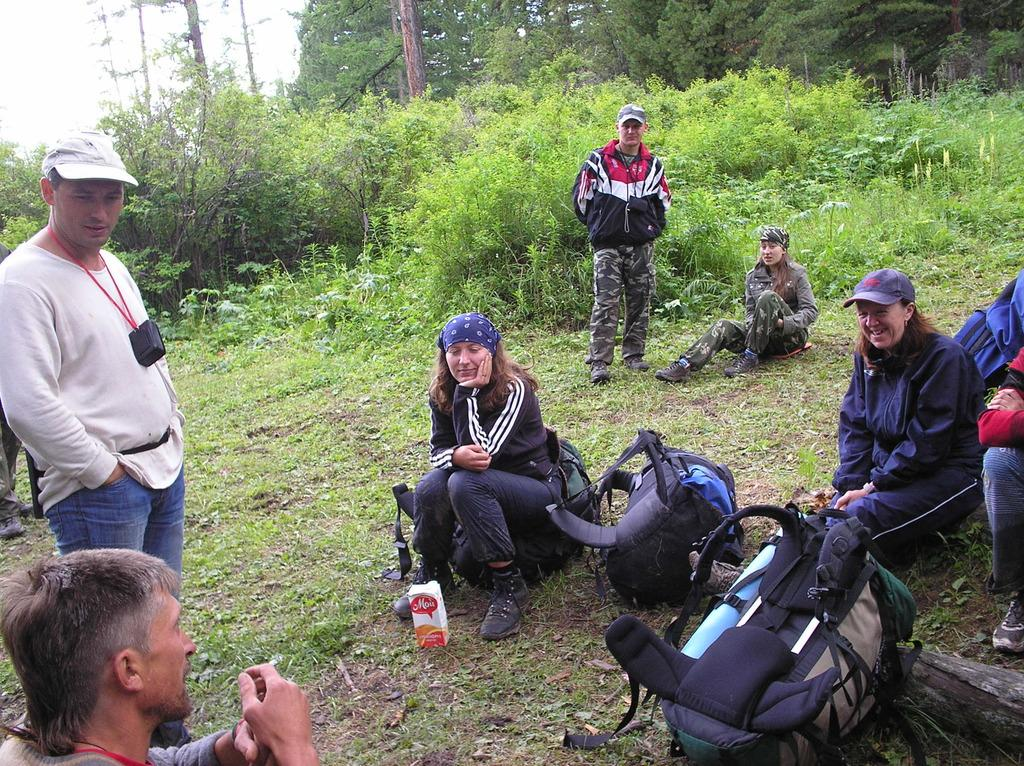What are the people in the image doing? There are people sitting on the grass and standing in the image. What objects can be seen in the front of the image? There are bags in the front of the image. What can be seen in the background of the image? There are plants and trees in the background of the image. What type of animal can be seen swimming in the water in the image? There is no water or animal present in the image; it features people sitting on the grass and standing, with bags in the front and plants and trees in the background. 